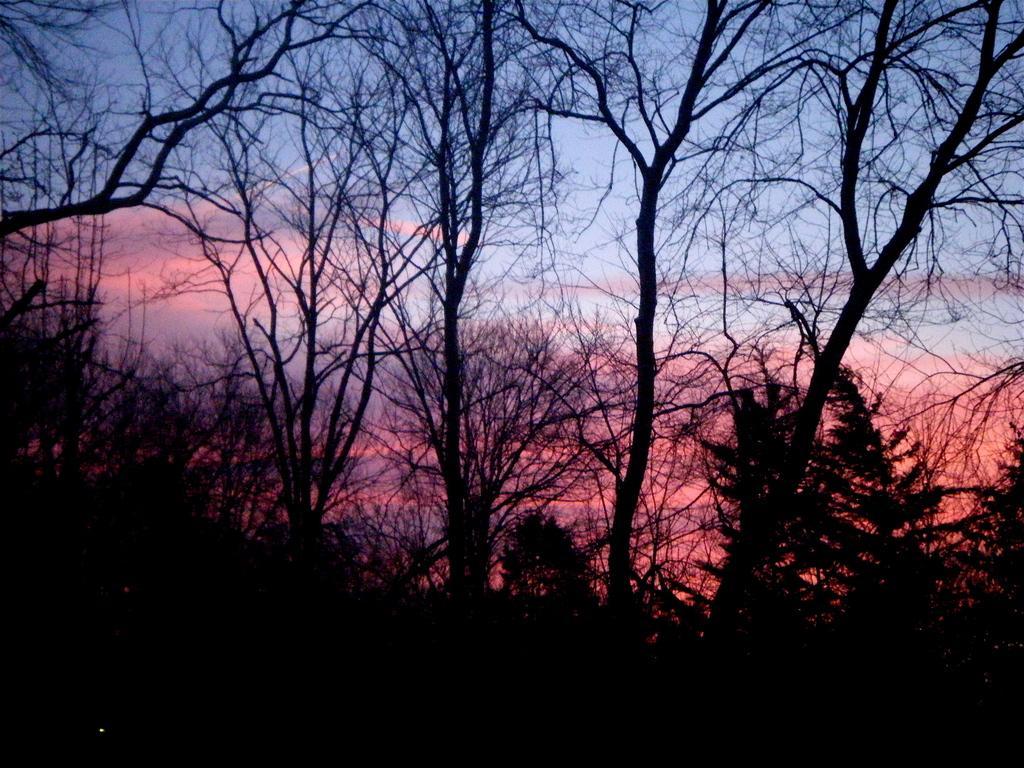In one or two sentences, can you explain what this image depicts? In this picture we can see many trees. On the top we can see orange clouds and sky. 